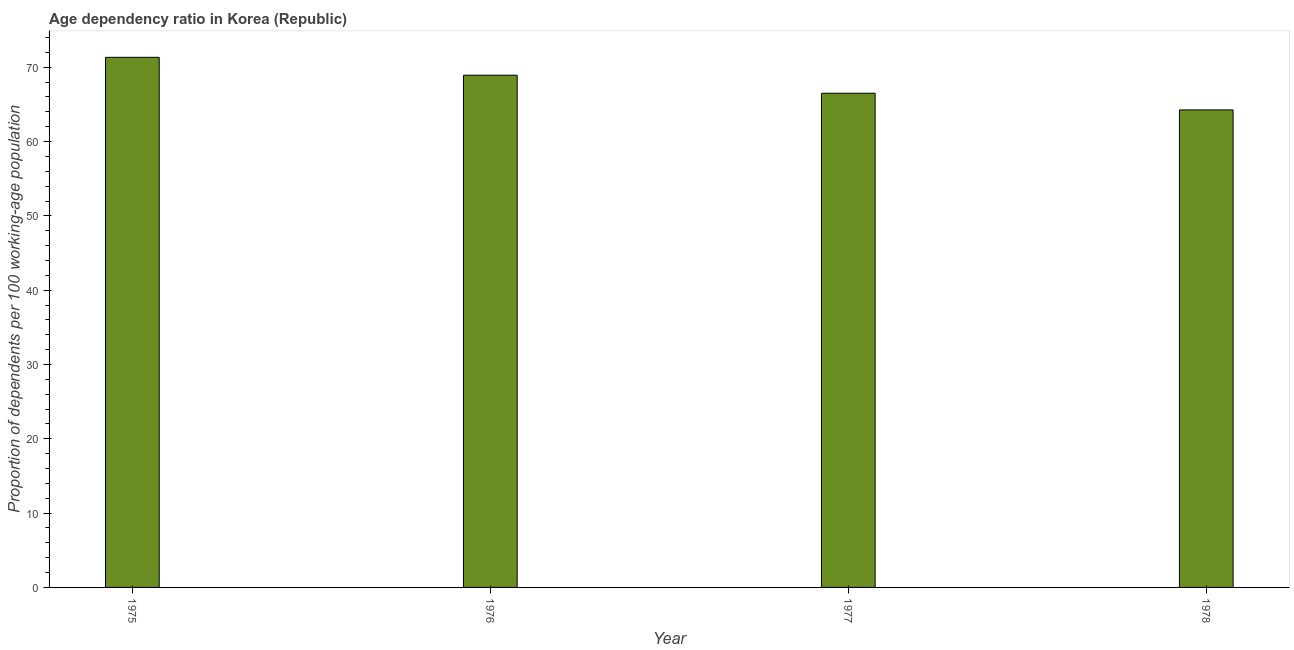What is the title of the graph?
Keep it short and to the point. Age dependency ratio in Korea (Republic). What is the label or title of the Y-axis?
Ensure brevity in your answer.  Proportion of dependents per 100 working-age population. What is the age dependency ratio in 1978?
Your response must be concise. 64.26. Across all years, what is the maximum age dependency ratio?
Provide a short and direct response. 71.33. Across all years, what is the minimum age dependency ratio?
Your answer should be very brief. 64.26. In which year was the age dependency ratio maximum?
Provide a short and direct response. 1975. In which year was the age dependency ratio minimum?
Make the answer very short. 1978. What is the sum of the age dependency ratio?
Make the answer very short. 271.02. What is the difference between the age dependency ratio in 1975 and 1977?
Your response must be concise. 4.83. What is the average age dependency ratio per year?
Make the answer very short. 67.75. What is the median age dependency ratio?
Offer a terse response. 67.71. What is the ratio of the age dependency ratio in 1975 to that in 1976?
Give a very brief answer. 1.03. Is the age dependency ratio in 1976 less than that in 1977?
Give a very brief answer. No. Is the difference between the age dependency ratio in 1975 and 1976 greater than the difference between any two years?
Your answer should be very brief. No. What is the difference between the highest and the second highest age dependency ratio?
Ensure brevity in your answer.  2.41. What is the difference between the highest and the lowest age dependency ratio?
Ensure brevity in your answer.  7.08. In how many years, is the age dependency ratio greater than the average age dependency ratio taken over all years?
Provide a succinct answer. 2. Are the values on the major ticks of Y-axis written in scientific E-notation?
Provide a succinct answer. No. What is the Proportion of dependents per 100 working-age population of 1975?
Your answer should be very brief. 71.33. What is the Proportion of dependents per 100 working-age population of 1976?
Your response must be concise. 68.93. What is the Proportion of dependents per 100 working-age population in 1977?
Offer a terse response. 66.5. What is the Proportion of dependents per 100 working-age population of 1978?
Offer a terse response. 64.26. What is the difference between the Proportion of dependents per 100 working-age population in 1975 and 1976?
Your answer should be compact. 2.41. What is the difference between the Proportion of dependents per 100 working-age population in 1975 and 1977?
Provide a succinct answer. 4.83. What is the difference between the Proportion of dependents per 100 working-age population in 1975 and 1978?
Offer a terse response. 7.08. What is the difference between the Proportion of dependents per 100 working-age population in 1976 and 1977?
Make the answer very short. 2.43. What is the difference between the Proportion of dependents per 100 working-age population in 1976 and 1978?
Provide a succinct answer. 4.67. What is the difference between the Proportion of dependents per 100 working-age population in 1977 and 1978?
Keep it short and to the point. 2.24. What is the ratio of the Proportion of dependents per 100 working-age population in 1975 to that in 1976?
Offer a terse response. 1.03. What is the ratio of the Proportion of dependents per 100 working-age population in 1975 to that in 1977?
Give a very brief answer. 1.07. What is the ratio of the Proportion of dependents per 100 working-age population in 1975 to that in 1978?
Offer a very short reply. 1.11. What is the ratio of the Proportion of dependents per 100 working-age population in 1976 to that in 1977?
Your response must be concise. 1.04. What is the ratio of the Proportion of dependents per 100 working-age population in 1976 to that in 1978?
Provide a succinct answer. 1.07. What is the ratio of the Proportion of dependents per 100 working-age population in 1977 to that in 1978?
Your answer should be compact. 1.03. 